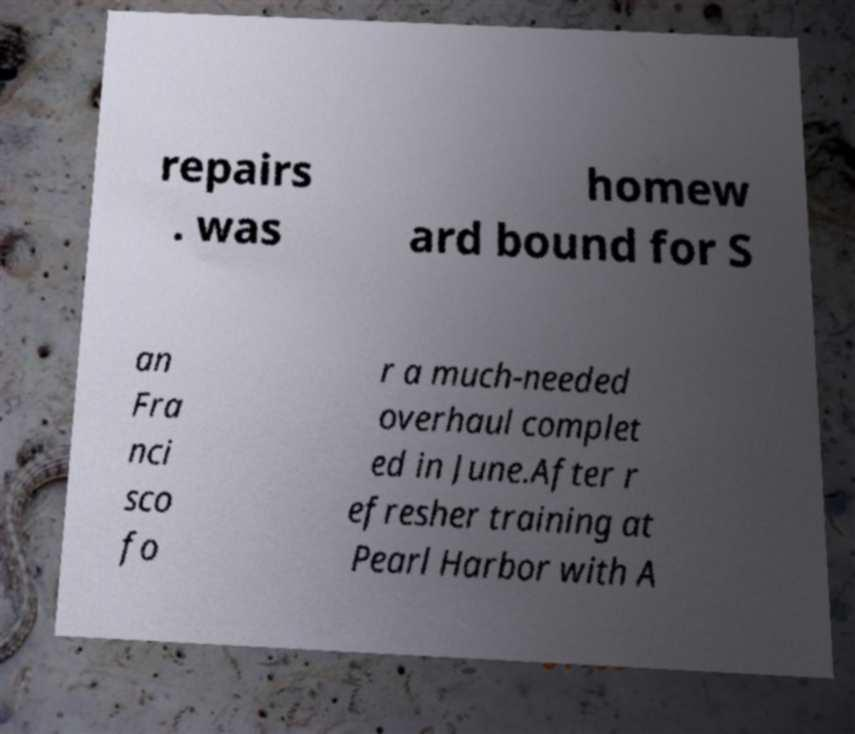For documentation purposes, I need the text within this image transcribed. Could you provide that? repairs . was homew ard bound for S an Fra nci sco fo r a much-needed overhaul complet ed in June.After r efresher training at Pearl Harbor with A 